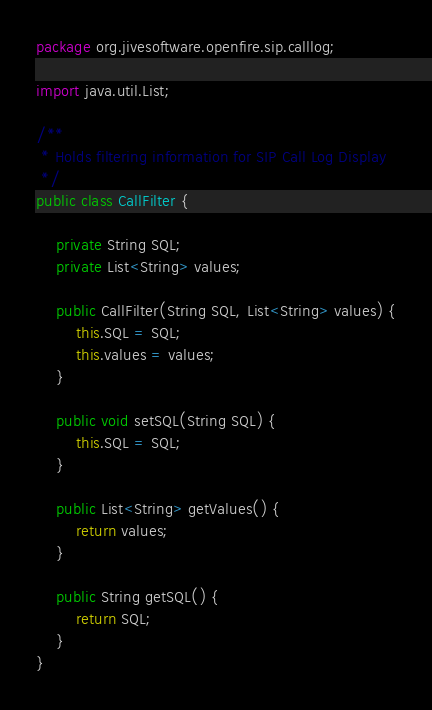<code> <loc_0><loc_0><loc_500><loc_500><_Java_>package org.jivesoftware.openfire.sip.calllog;

import java.util.List;

/**
 * Holds filtering information for SIP Call Log Display
 */
public class CallFilter {

    private String SQL;
    private List<String> values;

    public CallFilter(String SQL, List<String> values) {
        this.SQL = SQL;
        this.values = values;
    }

    public void setSQL(String SQL) {
        this.SQL = SQL;
    }

    public List<String> getValues() {
        return values;
    }

    public String getSQL() {
        return SQL;
    }
}</code> 